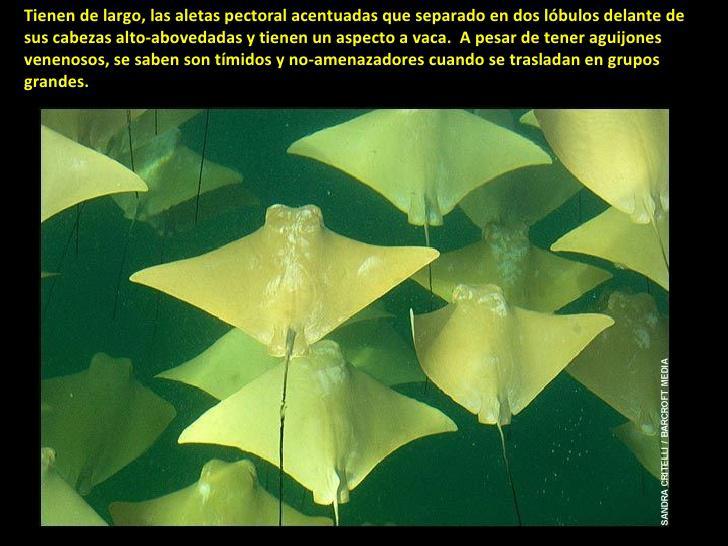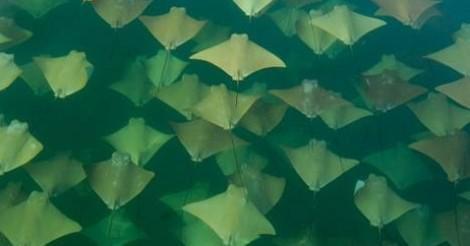The first image is the image on the left, the second image is the image on the right. Assess this claim about the two images: "An image shows a mass of stingrays in vivid blue water.". Correct or not? Answer yes or no. No. The first image is the image on the left, the second image is the image on the right. Examine the images to the left and right. Is the description "Animals are in blue water in the image on the right." accurate? Answer yes or no. No. 